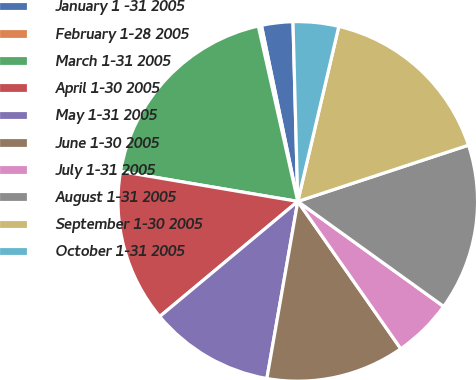Convert chart. <chart><loc_0><loc_0><loc_500><loc_500><pie_chart><fcel>January 1 -31 2005<fcel>February 1-28 2005<fcel>March 1-31 2005<fcel>April 1-30 2005<fcel>May 1-31 2005<fcel>June 1-30 2005<fcel>July 1-31 2005<fcel>August 1-31 2005<fcel>September 1-30 2005<fcel>October 1-31 2005<nl><fcel>2.82%<fcel>0.28%<fcel>18.81%<fcel>13.73%<fcel>11.19%<fcel>12.46%<fcel>5.36%<fcel>15.0%<fcel>16.27%<fcel>4.09%<nl></chart> 